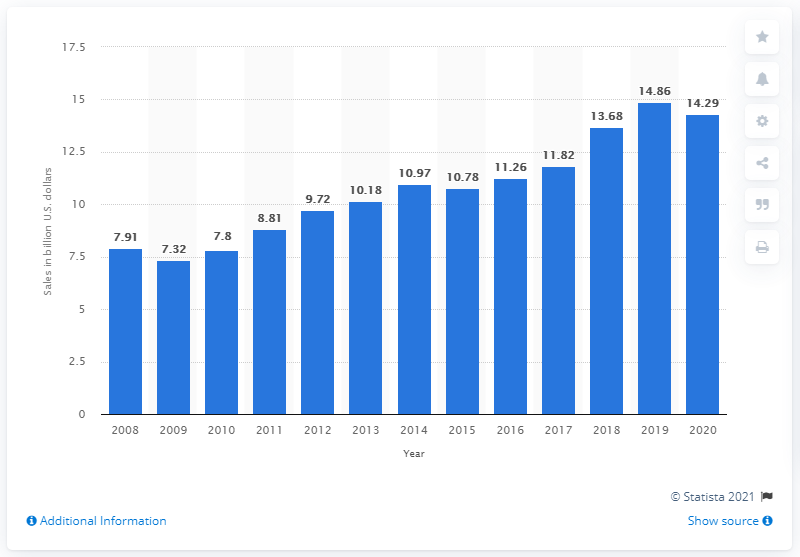Point out several critical features in this image. In 2020, Estée Lauder's net sales were 14.29 billion dollars. By the end of 2019, Estée Lauder's global net sales were 14.86 billion U.S. dollars. 